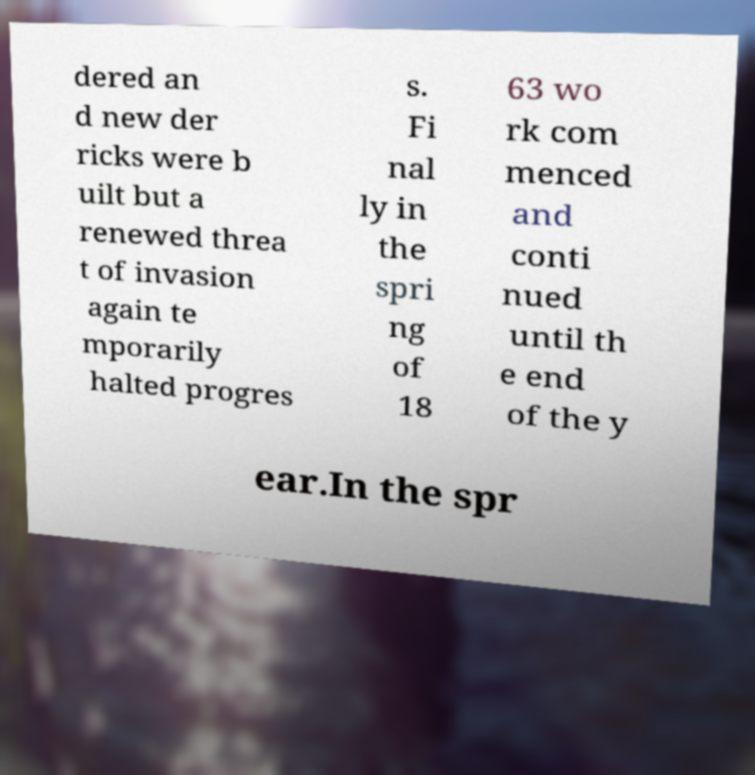Can you read and provide the text displayed in the image?This photo seems to have some interesting text. Can you extract and type it out for me? dered an d new der ricks were b uilt but a renewed threa t of invasion again te mporarily halted progres s. Fi nal ly in the spri ng of 18 63 wo rk com menced and conti nued until th e end of the y ear.In the spr 